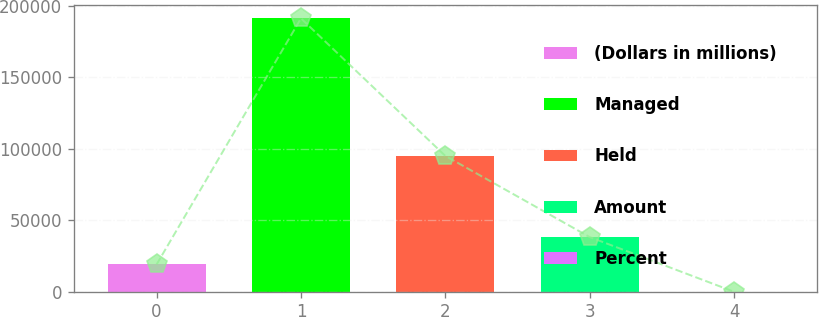<chart> <loc_0><loc_0><loc_500><loc_500><bar_chart><fcel>(Dollars in millions)<fcel>Managed<fcel>Held<fcel>Amount<fcel>Percent<nl><fcel>19134.8<fcel>191314<fcel>95076<fcel>38265.8<fcel>3.78<nl></chart> 